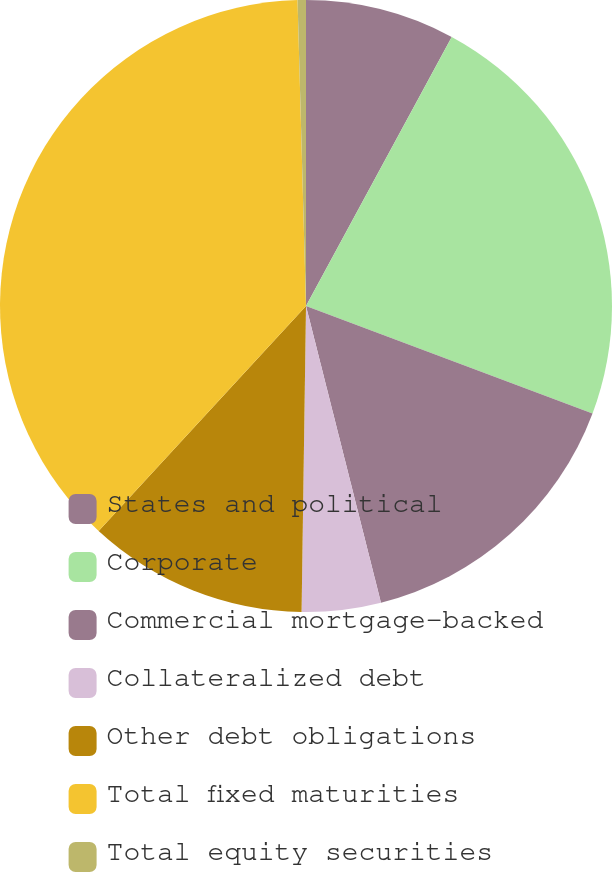<chart> <loc_0><loc_0><loc_500><loc_500><pie_chart><fcel>States and political<fcel>Corporate<fcel>Commercial mortgage-backed<fcel>Collateralized debt<fcel>Other debt obligations<fcel>Total fixed maturities<fcel>Total equity securities<nl><fcel>7.9%<fcel>22.81%<fcel>15.35%<fcel>4.17%<fcel>11.62%<fcel>37.71%<fcel>0.44%<nl></chart> 